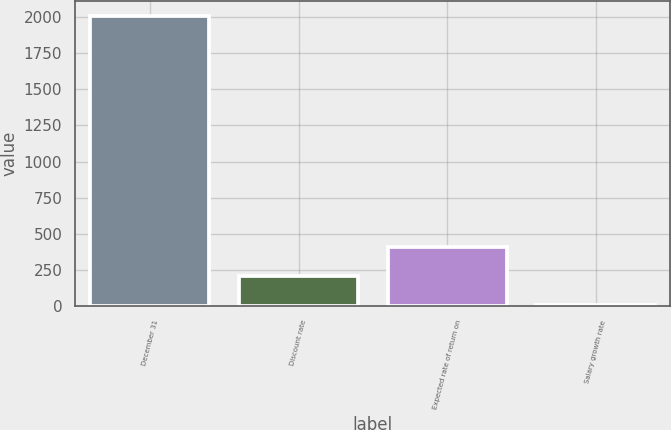Convert chart. <chart><loc_0><loc_0><loc_500><loc_500><bar_chart><fcel>December 31<fcel>Discount rate<fcel>Expected rate of return on<fcel>Salary growth rate<nl><fcel>2011<fcel>205.15<fcel>405.8<fcel>4.5<nl></chart> 